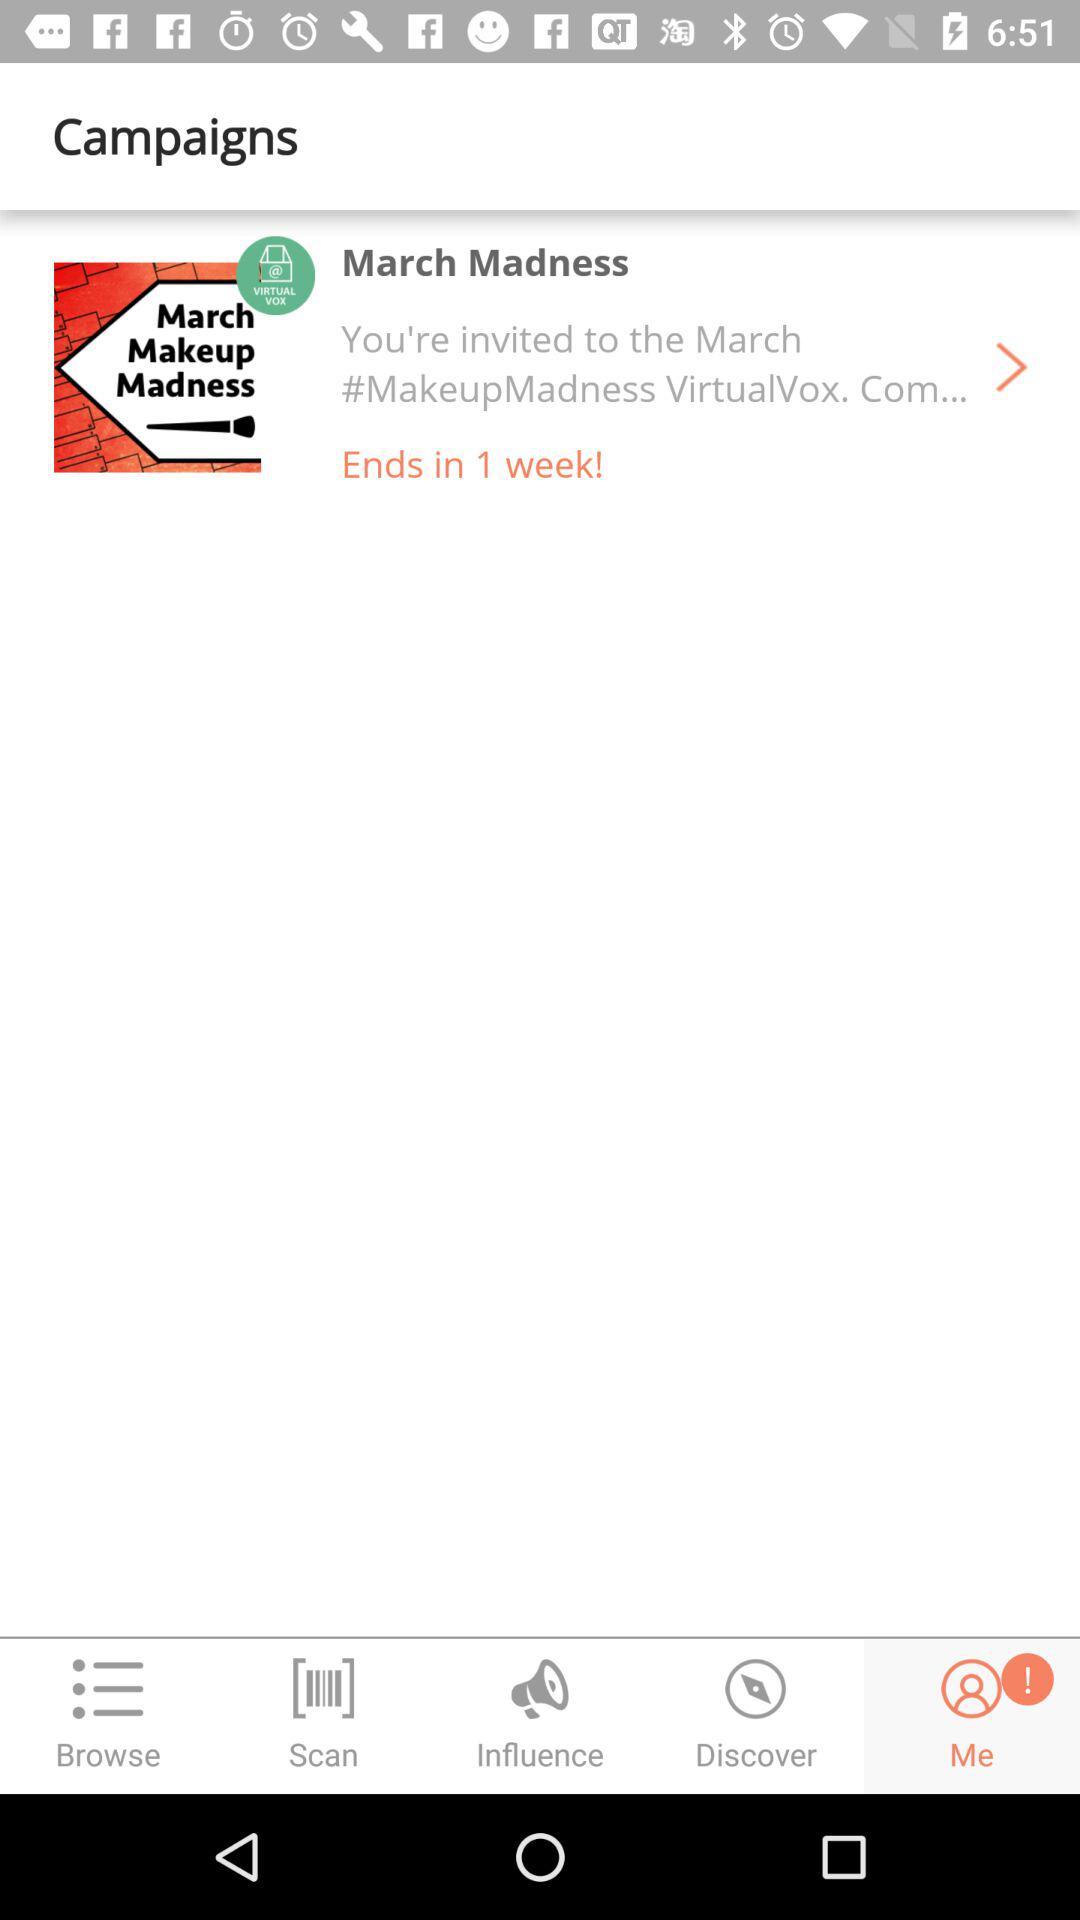Which tab is selected? The selected tab is "Me". 